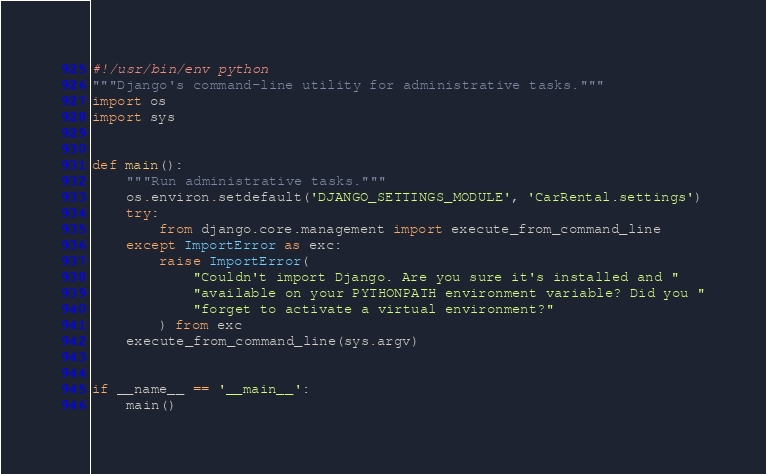<code> <loc_0><loc_0><loc_500><loc_500><_Python_>#!/usr/bin/env python
"""Django's command-line utility for administrative tasks."""
import os
import sys


def main():
    """Run administrative tasks."""
    os.environ.setdefault('DJANGO_SETTINGS_MODULE', 'CarRental.settings')
    try:
        from django.core.management import execute_from_command_line
    except ImportError as exc:
        raise ImportError(
            "Couldn't import Django. Are you sure it's installed and "
            "available on your PYTHONPATH environment variable? Did you "
            "forget to activate a virtual environment?"
        ) from exc
    execute_from_command_line(sys.argv)


if __name__ == '__main__':
    main()
</code> 